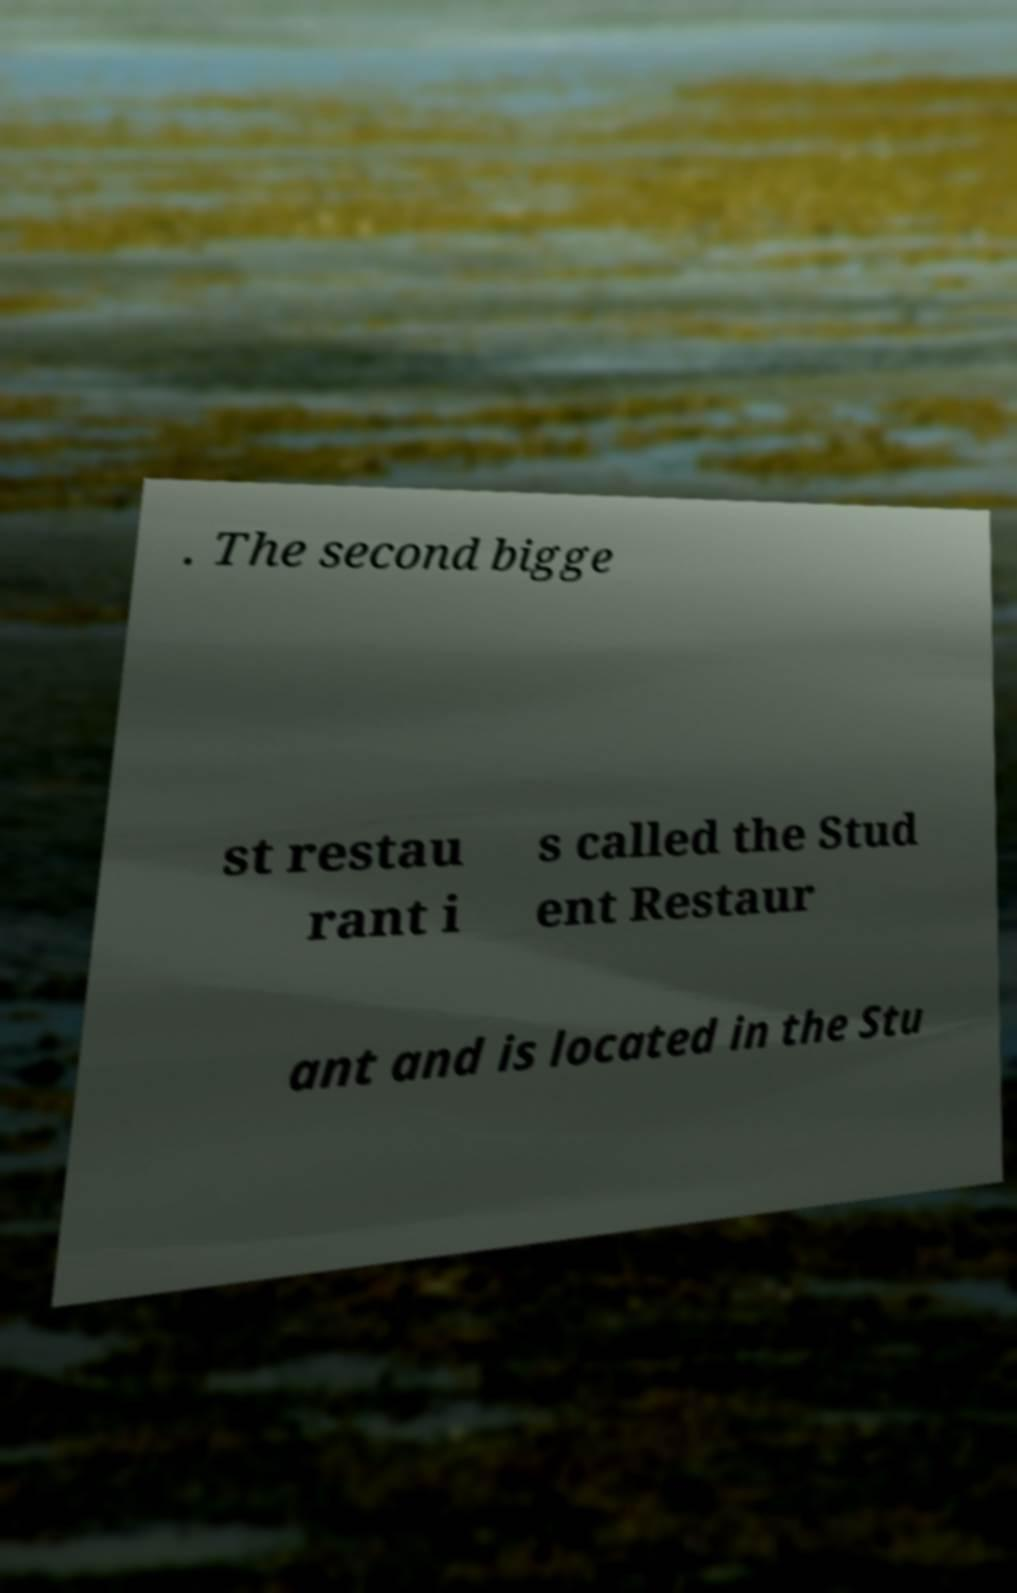Please read and relay the text visible in this image. What does it say? . The second bigge st restau rant i s called the Stud ent Restaur ant and is located in the Stu 